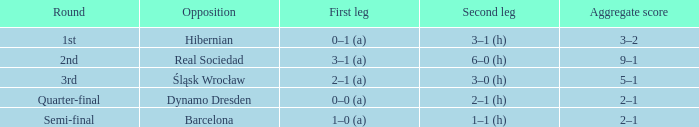Who were the opposition in the quarter-final? Dynamo Dresden. 